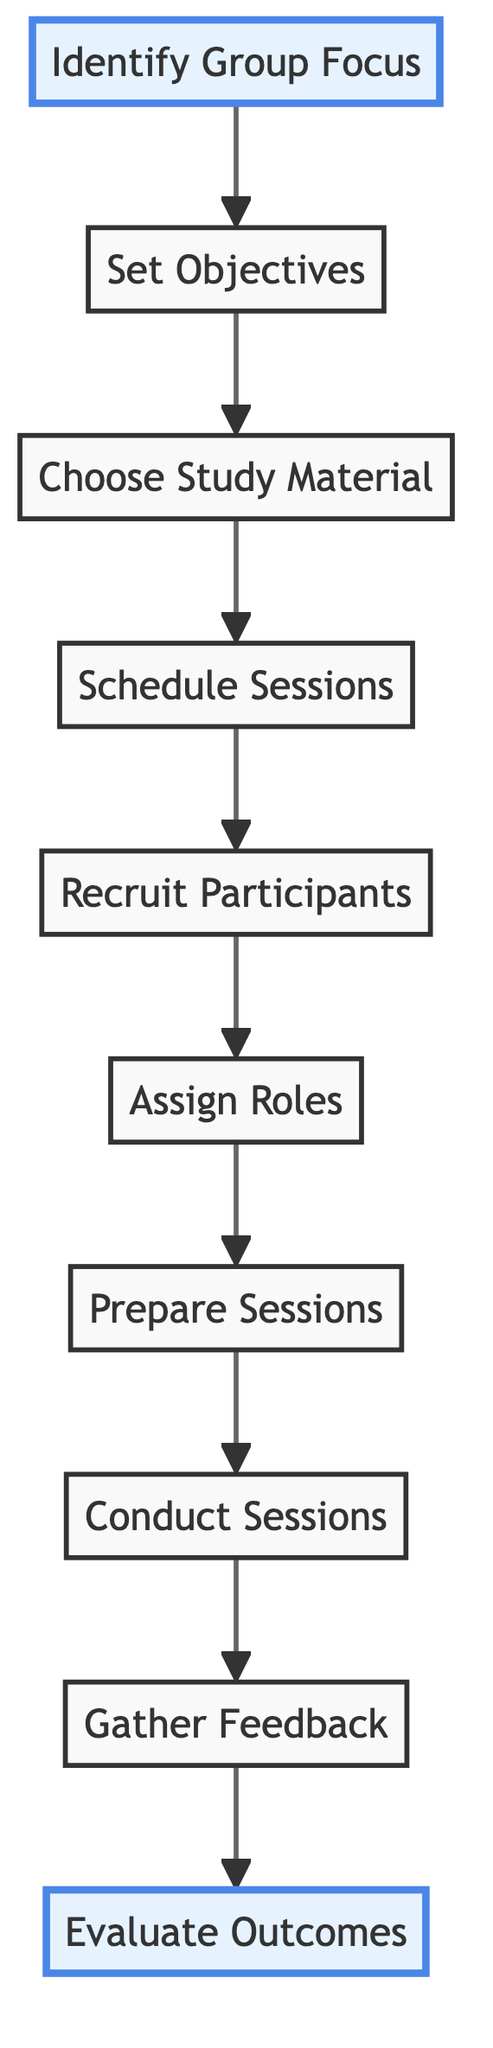What is the first step in the process? The first step indicated in the diagram is "Identify Group Focus." It's the starting point of the flow, which sets the direction for the rest of the planning process.
Answer: Identify Group Focus How many steps are there in the process? By counting each node in the diagram, there are a total of 10 steps, which trace the full course of planning a Bible study session.
Answer: 10 What is the last step of the process? The last step in the flow chart is "Evaluate Outcomes," marking the conclusion of the planning process. It assesses the effectiveness of the session in meeting objectives.
Answer: Evaluate Outcomes What follows "Schedule Sessions"? The action that follows "Schedule Sessions" is "Recruit Participants." This step involves inviting individuals to join and participate in the study group.
Answer: Recruit Participants What is the relationship between "Conduct Sessions" and "Gather Feedback"? "Conduct Sessions" directly leads to "Gather Feedback." After sessions are held, it's crucial to collect participants' feedback to make improvements for future meetings.
Answer: Gather Feedback What are the objectives of the group based on the second step? The objectives are defined in the "Set Objectives" step, where the goals for what participants should achieve are established during the planning process.
Answer: Set Objectives Which step includes preparing discussion questions and prayer points? The "Prepare Sessions" step encompasses the preparation of discussion questions, prayer points, and activities necessary for conducting each session effectively.
Answer: Prepare Sessions What is more important, "Assign Roles" or "Choose Study Material"? "Assign Roles" is an essential step (step 6) that occurs after "Choose Study Material" (step 3). Each step is important, but "Assign Roles" is crucial for effective group management.
Answer: Assign Roles What comes right before "Evaluate Outcomes"? "Gather Feedback" directly precedes "Evaluate Outcomes." Collecting feedback is essential for determining how well the objectives were met in the sessions.
Answer: Gather Feedback Which step emphasizes inviting congregation members? The step specifically focused on inviting congregation members is "Recruit Participants." This is where the group expands by encouraging others to join the Bible study.
Answer: Recruit Participants 